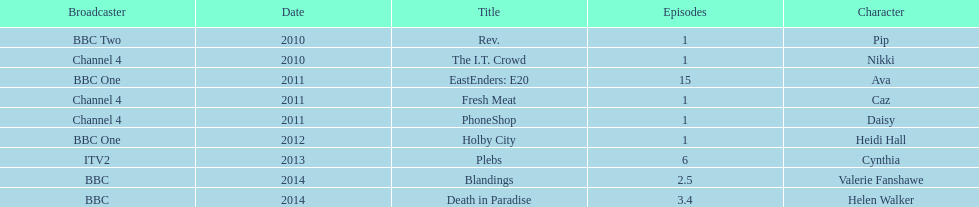Could you parse the entire table? {'header': ['Broadcaster', 'Date', 'Title', 'Episodes', 'Character'], 'rows': [['BBC Two', '2010', 'Rev.', '1', 'Pip'], ['Channel 4', '2010', 'The I.T. Crowd', '1', 'Nikki'], ['BBC One', '2011', 'EastEnders: E20', '15', 'Ava'], ['Channel 4', '2011', 'Fresh Meat', '1', 'Caz'], ['Channel 4', '2011', 'PhoneShop', '1', 'Daisy'], ['BBC One', '2012', 'Holby City', '1', 'Heidi Hall'], ['ITV2', '2013', 'Plebs', '6', 'Cynthia'], ['BBC', '2014', 'Blandings', '2.5', 'Valerie Fanshawe'], ['BBC', '2014', 'Death in Paradise', '3.4', 'Helen Walker']]} Blandings and death in paradise both aired on which broadcaster? BBC. 